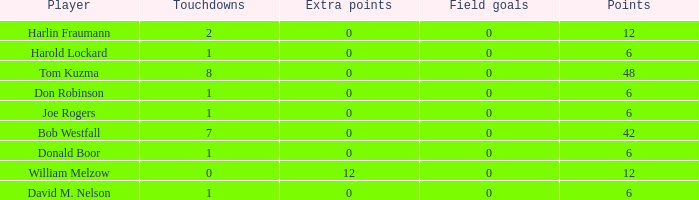Name the least touchdowns for joe rogers 1.0. 